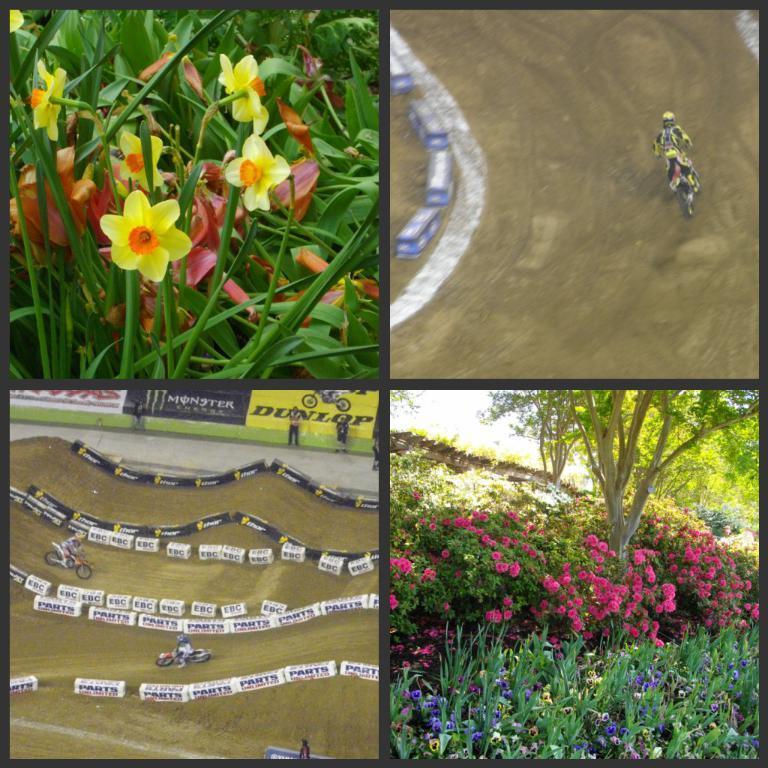Can you describe this image briefly? This is collage image, in this image there are four pictures, in one picture there are flowers and leaves, in second picture a man riding a bike on soil land, in third picture there are two man riding bikes on soil land, in fourth picture there are flower and trees. 